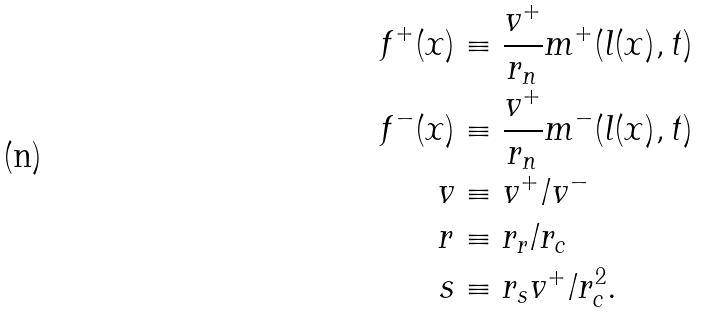Convert formula to latex. <formula><loc_0><loc_0><loc_500><loc_500>f ^ { + } ( x ) & \equiv \frac { v ^ { + } } { r _ { n } } m ^ { + } ( l ( x ) , t ) \\ f ^ { - } ( x ) & \equiv \frac { v ^ { + } } { r _ { n } } m ^ { - } ( l ( x ) , t ) \\ v & \equiv v ^ { + } / v ^ { - } \\ r & \equiv r _ { r } / r _ { c } \\ s & \equiv r _ { s } v ^ { + } / r _ { c } ^ { 2 } .</formula> 